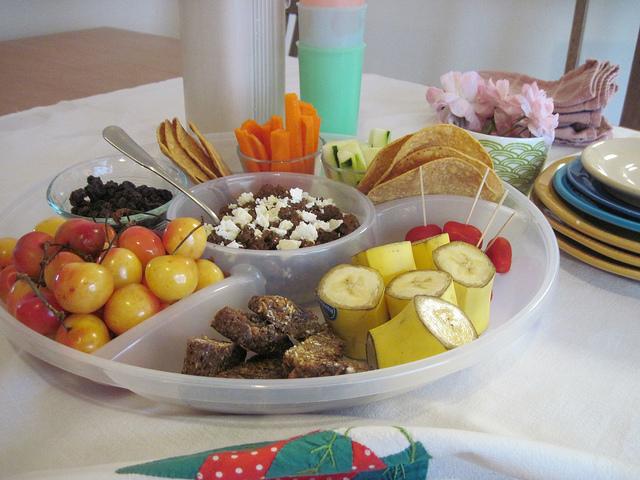Is this a restaurant?
Answer briefly. No. Is this a cake?
Concise answer only. No. What type of vegetable in the bowl?
Answer briefly. Carrots. Are these low calorie items?
Quick response, please. Yes. What is mainly featured?
Quick response, please. Fruit. Is there more than one kind of fruit on the tray?
Quick response, please. Yes. What color is the divided bowl?
Quick response, please. Clear. 